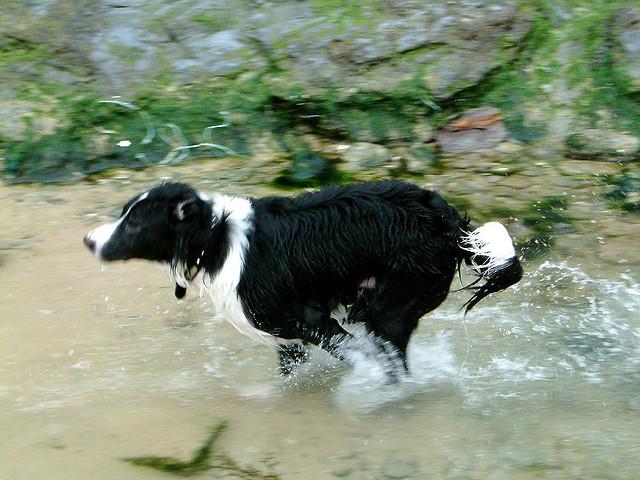Does this dog live in the wild?
Quick response, please. No. Is there a collar on the dog?
Answer briefly. Yes. Is the dog in the water?
Quick response, please. Yes. 